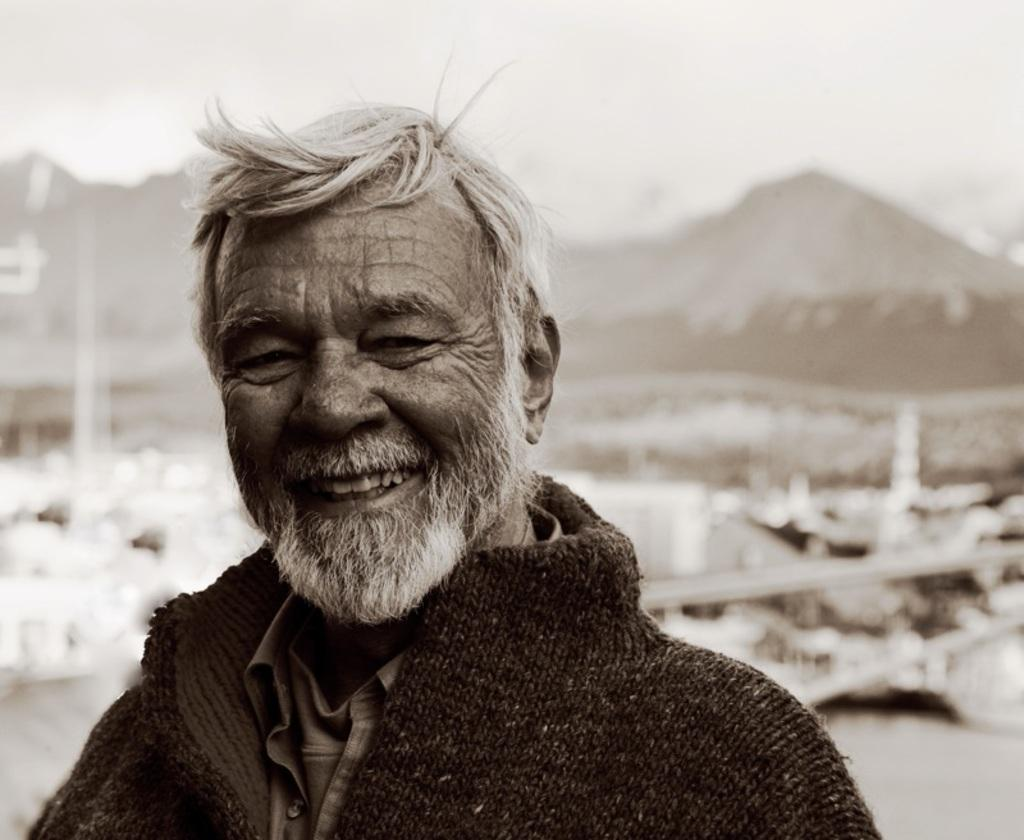What is the main subject of the image? There is a person in the image. Can you describe the background of the image? The background of the image is blurred. What type of battle is taking place in the image? There is no battle present in the image; it features a person with a blurred background. What scent can be detected from the person in the image? There is no information about the scent of the person in the image. 